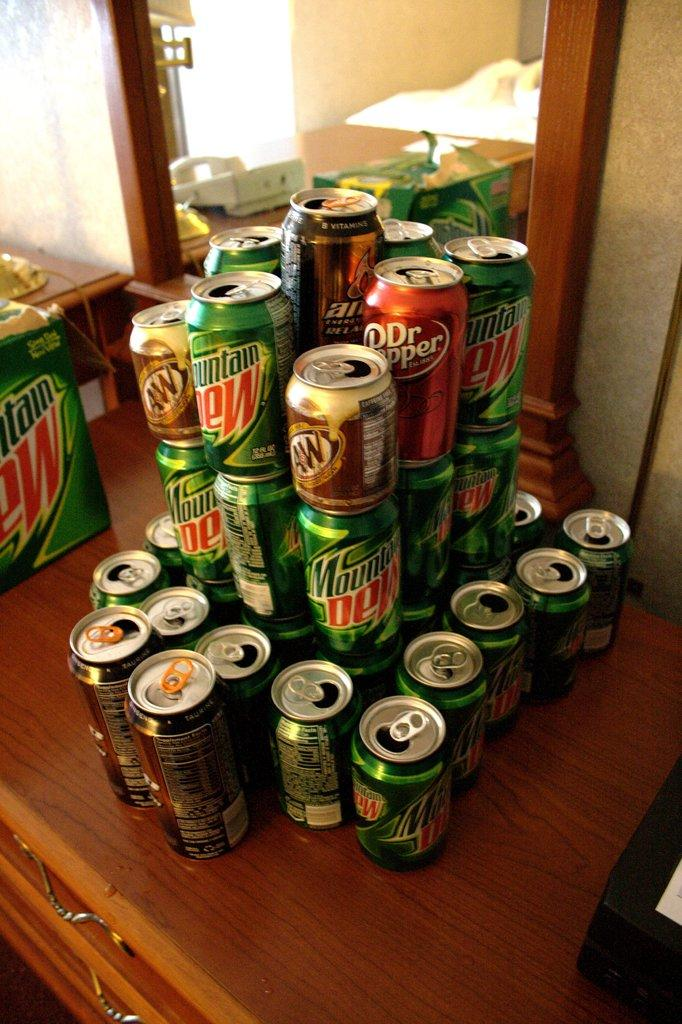<image>
Describe the image concisely. A stack of Mountain Dew cans and Dr. Pepper cans. 